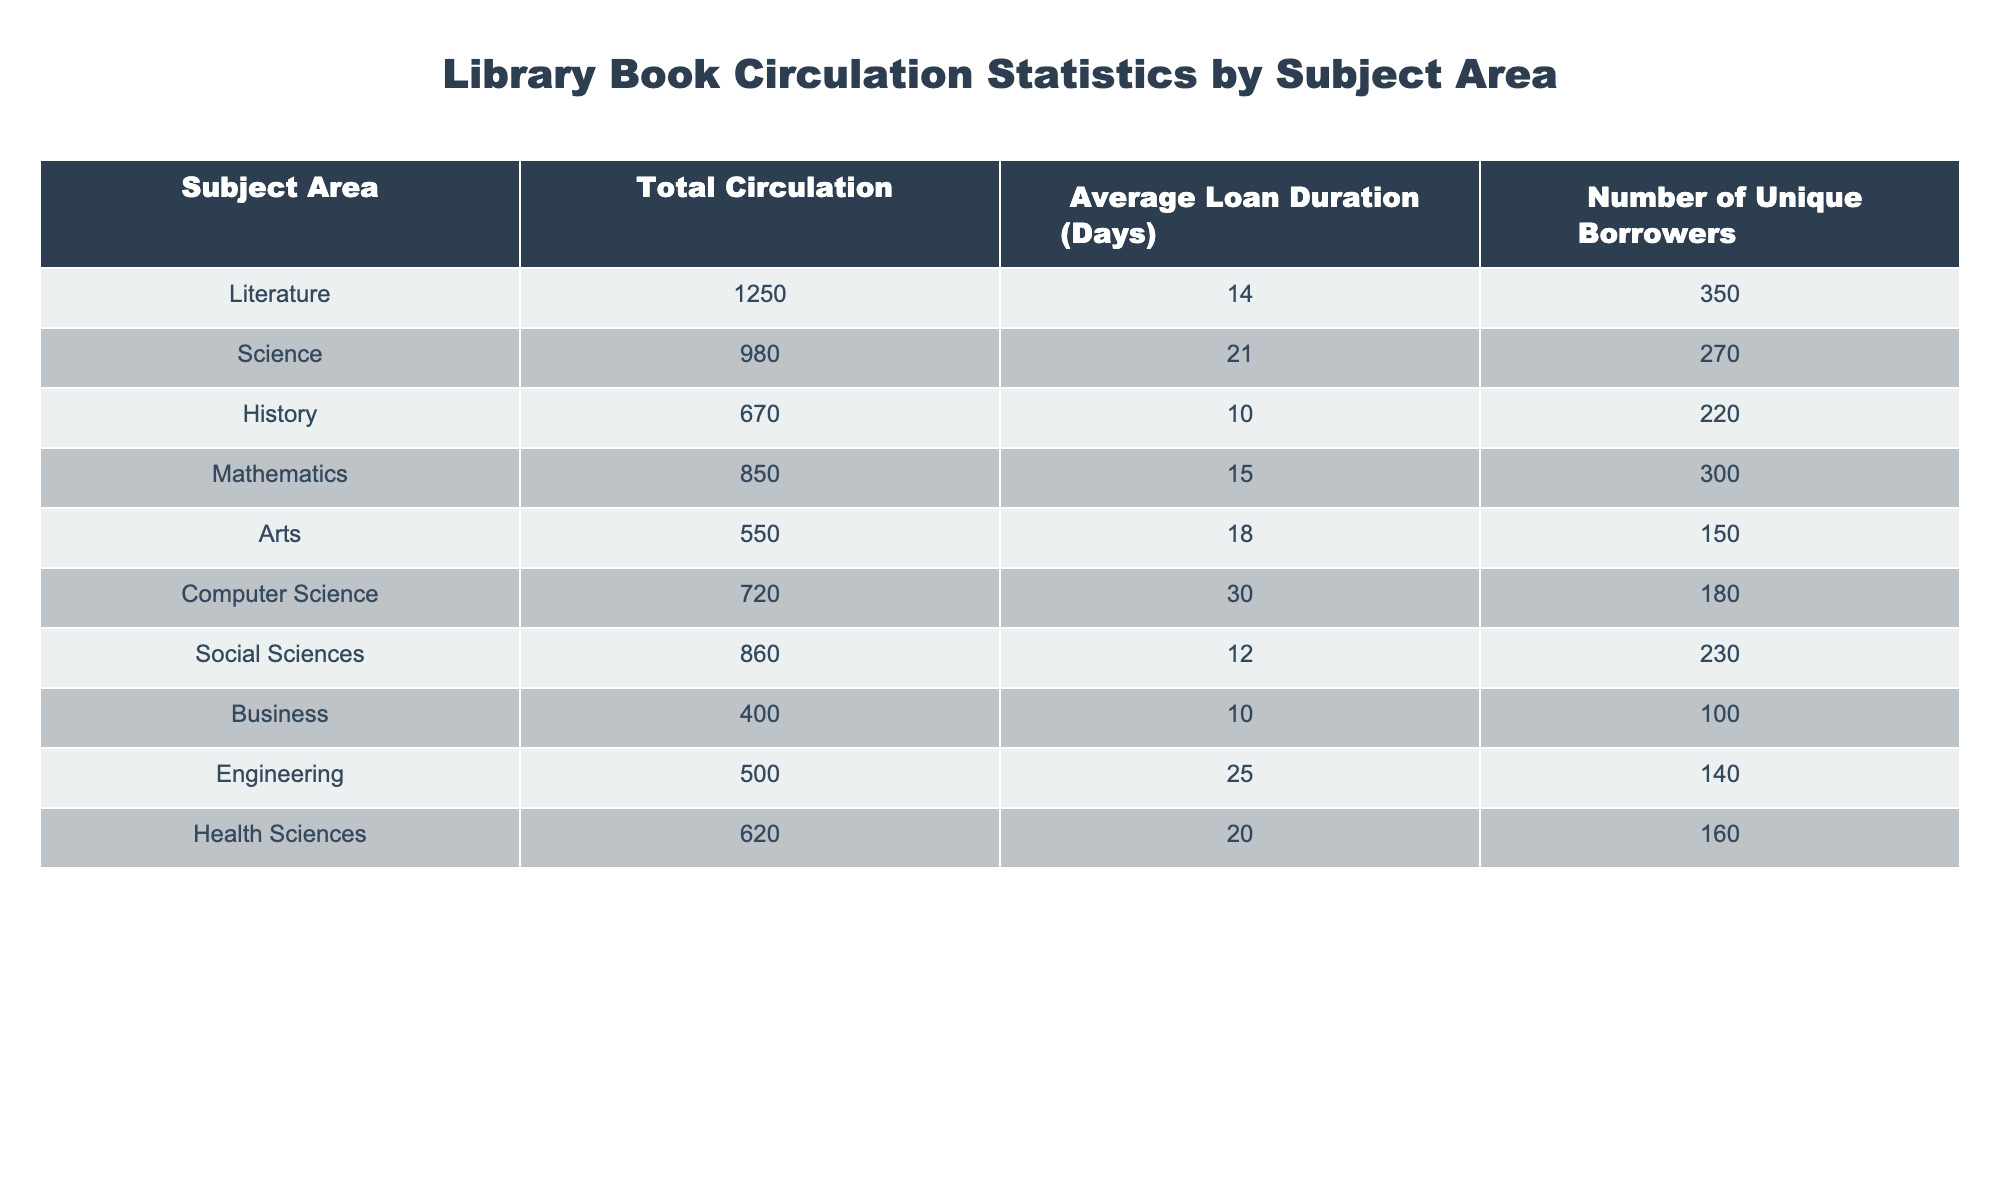What is the subject area with the highest total circulation? Looking at the Total Circulation column, the highest value is 1250, which corresponds to the Literature subject area.
Answer: Literature How many unique borrowers checked out books in the Science subject area? The Number of Unique Borrowers column shows that there are 270 unique borrowers for the Science subject area.
Answer: 270 What is the average loan duration for the Arts subject area? By checking the Average Loan Duration (Days) column, the value for Arts is 18 days.
Answer: 18 Is the average loan duration for Computer Science greater than 20 days? Referring to the Average Loan Duration (Days) for Computer Science, which is 30 days, it is indeed greater than 20 days.
Answer: Yes What is the total circulation of Health Sciences and Social Sciences combined? Adding the Total Circulation for Health Sciences (620) and Social Sciences (860) gives us 620 + 860 = 1480.
Answer: 1480 What subject area has the least number of unique borrowers? Looking through the Number of Unique Borrowers, the Business subject area has the least with 100 unique borrowers.
Answer: Business How does the average loan duration of Mathematics compare to that of History? Mathematics has an average loan duration of 15 days, while History has 10 days. Since 15 is greater than 10, Mathematics has a longer average loan duration.
Answer: Mathematics is longer What is the difference in total circulation between Engineering and Arts? The Total Circulation for Engineering is 500 and for Arts is 550, so we subtract 500 from 550, resulting in a difference of 50.
Answer: 50 Are there more unique borrowers for Literature than for Health Sciences? Literature has 350 unique borrowers, while Health Sciences has 160. Since 350 is greater than 160, there are more unique borrowers for Literature.
Answer: Yes 